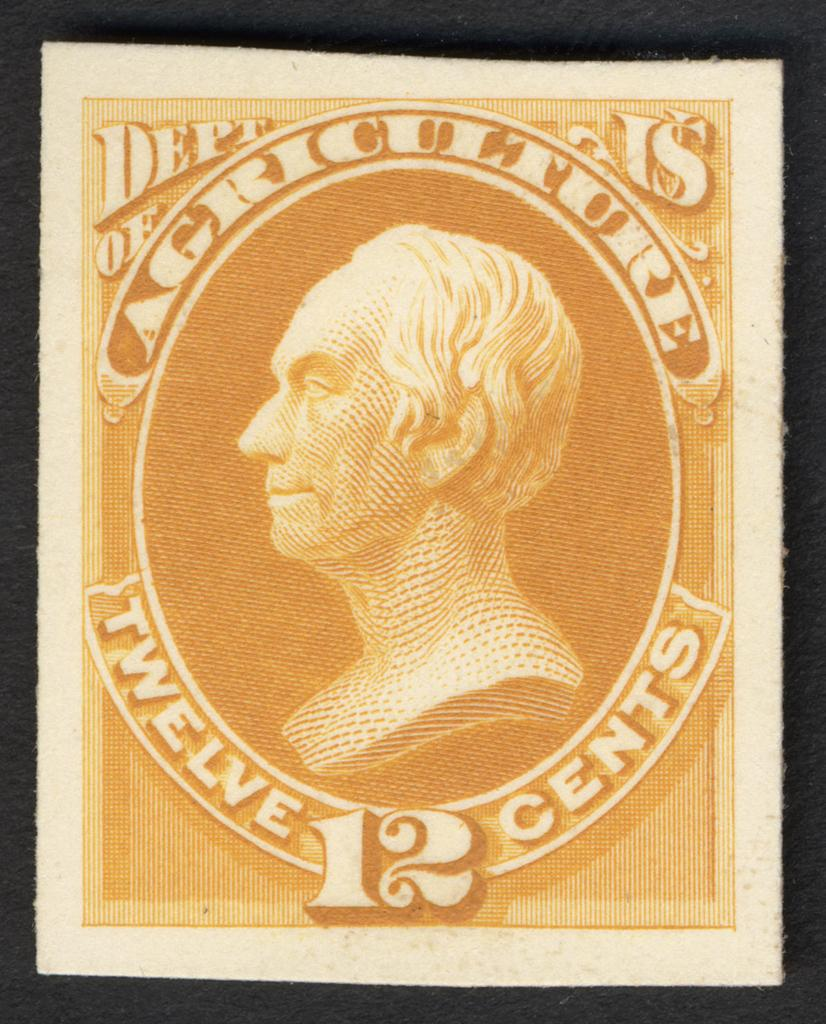What is the main object in the image? There is a stamp in the image. What is depicted on the stamp? The stamp has an image of a person. What else can be seen on the stamp besides the image of the person? The image of the person is surrounded by text. What type of belief is represented by the thing in the image? There is no "thing" present in the image; it features a stamp with an image of a person surrounded by text. What event is depicted in the image? The image in the stamp may represent a historical figure or event, but the image itself is not an event. 